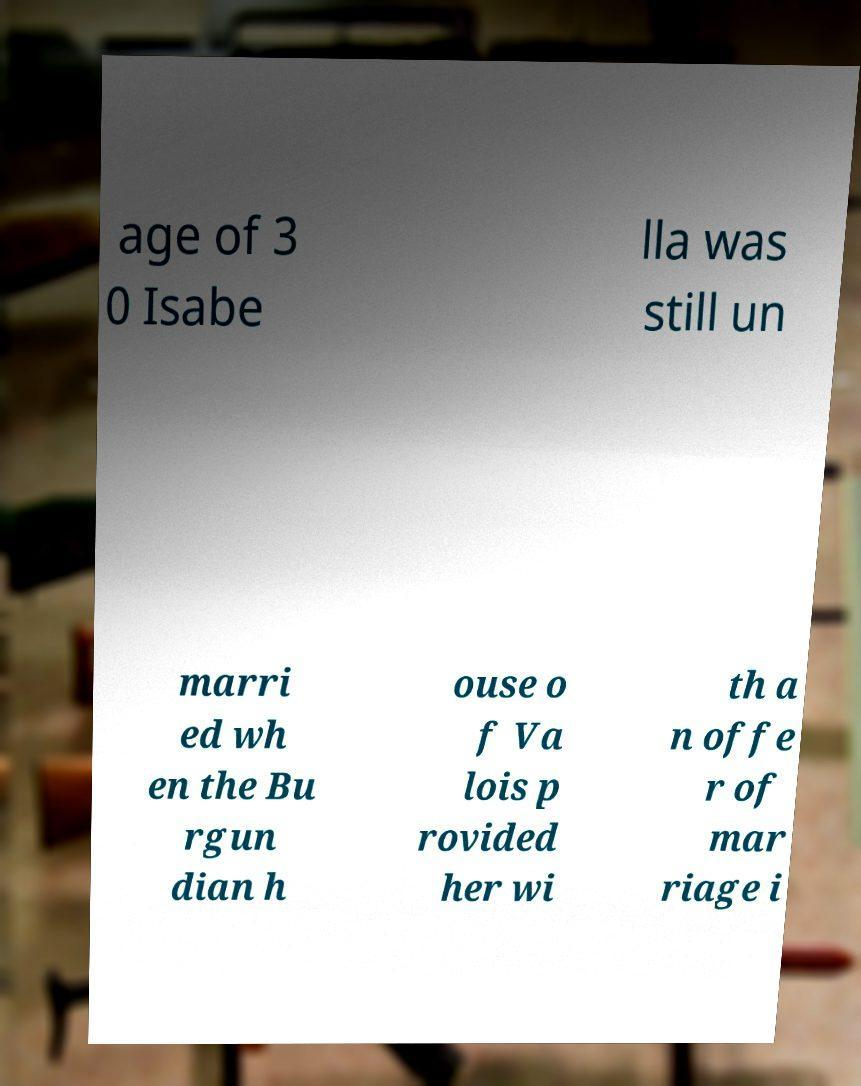What messages or text are displayed in this image? I need them in a readable, typed format. age of 3 0 Isabe lla was still un marri ed wh en the Bu rgun dian h ouse o f Va lois p rovided her wi th a n offe r of mar riage i 